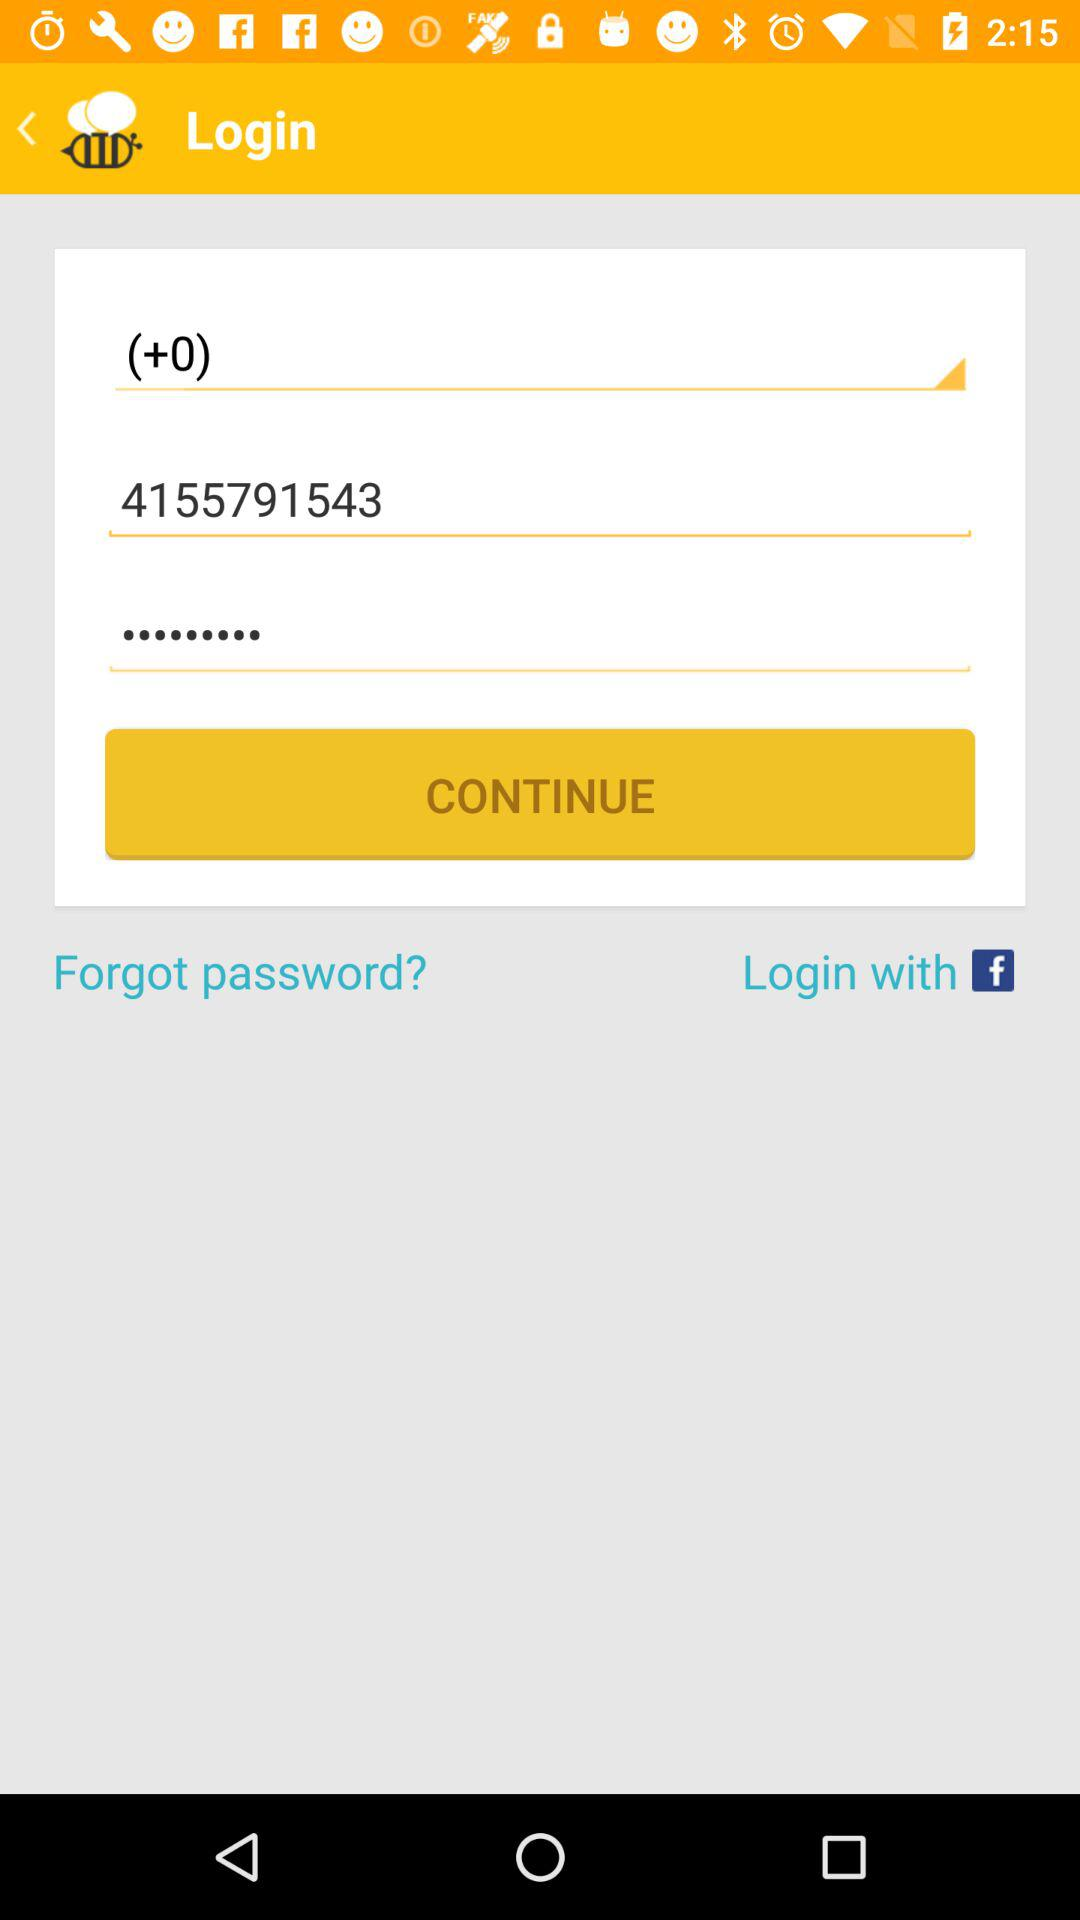What is the phone number? The phone number is (+0) 4155791543. 